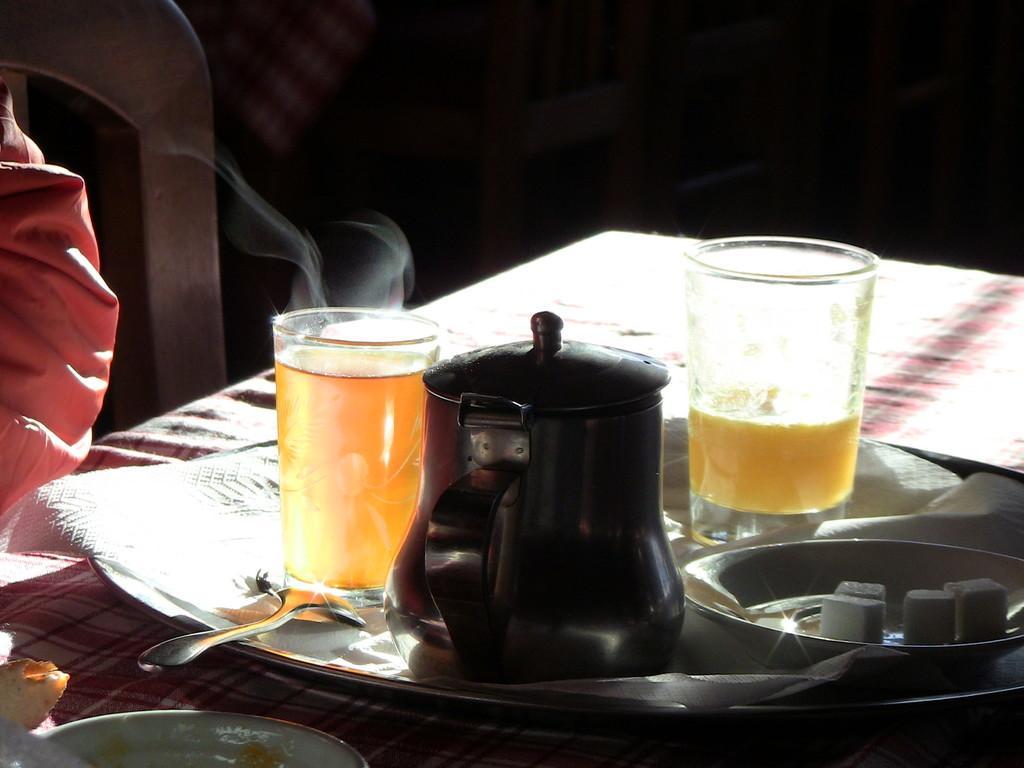Can you describe this image briefly? In this image there is a table, on that table there is a plate, in that plate there are glasses, in that glasses there is a liquid and a jar, spoon, bowl in that bowl there is a food item, beside the table there is a chair, in that chair there is a person sitting, in the background it is dark. 